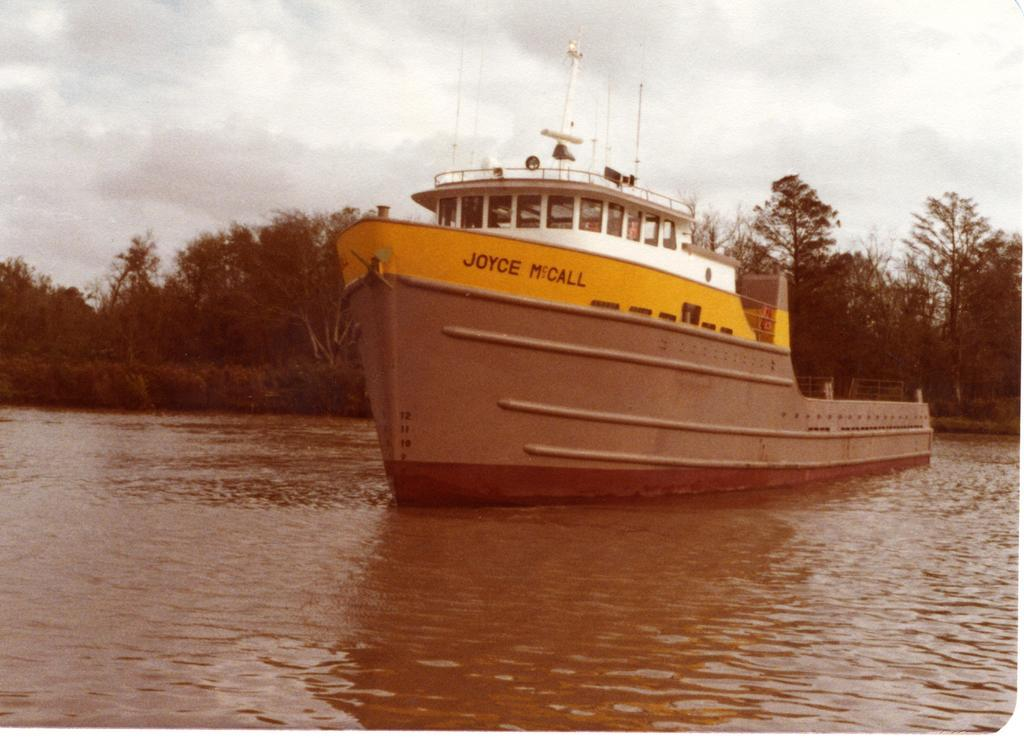What is the main subject of the image? The main subject of the image is a ship in the water body. What can be seen in the background of the image? There are trees in the background of the image. How would you describe the sky in the image? The sky is cloudy in the image. What type of rhythm can be heard coming from the ship in the image? There is no sound or rhythm present in the image, as it is a still photograph. 